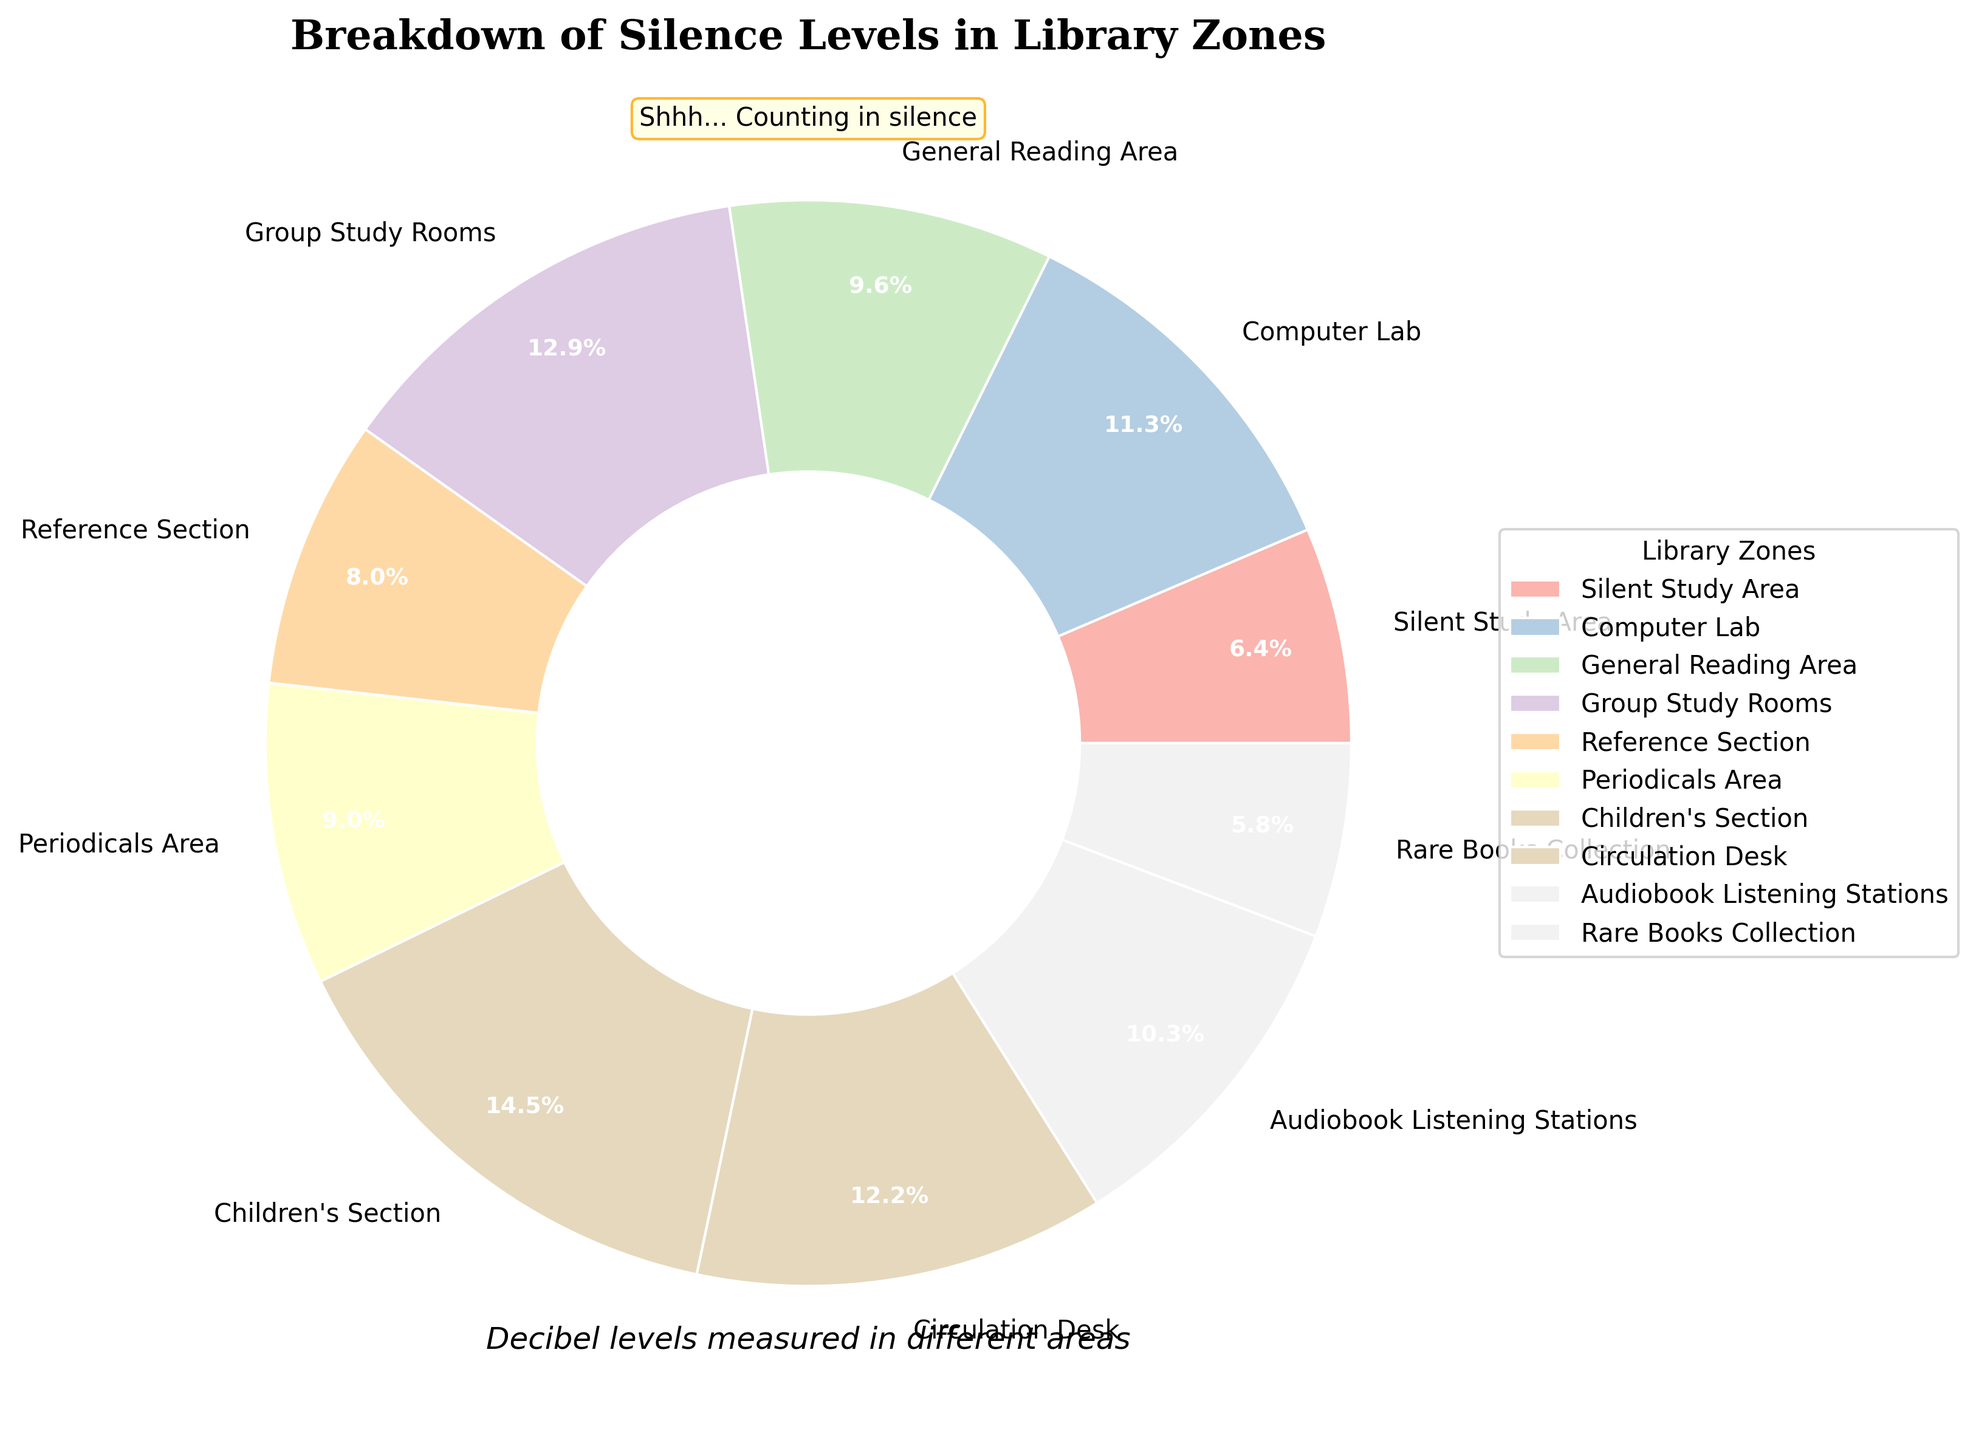How many zones have decibel levels greater than 35? We need to count the number of zones where the decibel level exceeds 35. The zones are Computer Lab (35), General Reading Area (30), Group Study Rooms (40), Children’s Section (45), and Circulation Desk (38). The Group Study Rooms, Children’s Section, and Circulation Desk all exceed 35.
Answer: 3 Which zone has the highest decibel level? To find the highest decibel level, we compare the levels of all zones. The Children’s Section has the highest decibel level at 45.
Answer: Children's Section Which zone has the lowest decibel level? To find the lowest decibel level, we compare the levels of all zones. The Rare Books Collection has the lowest decibel level at 18.
Answer: Rare Books Collection What is the average decibel level across all library zones? To calculate the average decibel level, sum up all decibel levels and divide by the number of zones. The sum is 311, and there are 10 zones. The average is 311/10 = 31.1.
Answer: 31.1 Which zones have decibel levels that are within 5 units of the average decibel level? First, calculate the average decibel level (31.1). Zones within 5 units would be between 26.1 and 36.1. These zones are Computer Lab (35), General Reading Area (30), Reference Section (25), Periodicals Area (28), and Audiobook Listening Stations (32).
Answer: Computer Lab, General Reading Area, Reference Section, Periodicals Area, Audiobook Listening Stations What is the total decibel level of the Silent Study Area and the Rare Books Collection combined? Sum the decibel levels of the Silent Study Area (20) and Rare Books Collection (18). The total is 20 + 18 = 38.
Answer: 38 How many zones have decibel levels less than 30? We need to count the number of zones where the decibel level is less than 30. These zones are Silent Study Area (20), Reference Section (25), Periodicals Area (28), and Rare Books Collection (18).
Answer: 4 By how much does the decibel level of the Children’s Section exceed that of the Silent Study Area? Subtract the decibel level of the Silent Study Area (20) from the level of the Children’s Section (45). The difference is 45 - 20 = 25.
Answer: 25 Is the decibel level of the Group Study Rooms more than, less than, or equal to the Circulation Desk? Compare the decibel levels directly. Group Study Rooms (40) is more than Circulation Desk (38).
Answer: More 